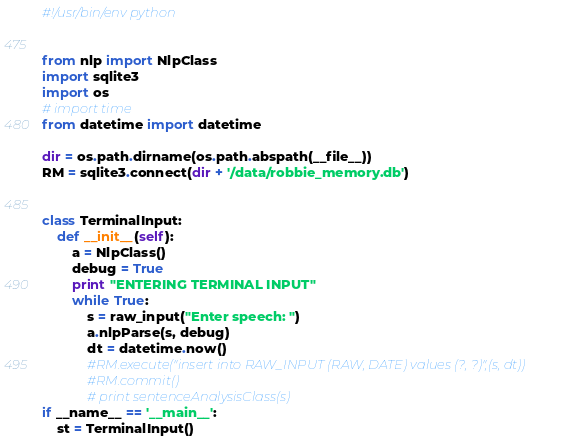Convert code to text. <code><loc_0><loc_0><loc_500><loc_500><_Python_>#!/usr/bin/env python


from nlp import NlpClass
import sqlite3
import os
# import time
from datetime import datetime

dir = os.path.dirname(os.path.abspath(__file__))
RM = sqlite3.connect(dir + '/data/robbie_memory.db')


class TerminalInput:
    def __init__(self):
        a = NlpClass()
        debug = True
        print "ENTERING TERMINAL INPUT"
        while True:
            s = raw_input("Enter speech: ")
            a.nlpParse(s, debug)
            dt = datetime.now()
            #RM.execute("insert into RAW_INPUT (RAW, DATE) values (?, ?)",(s, dt))
            #RM.commit()
            # print sentenceAnalysisClass(s)
if __name__ == '__main__':
    st = TerminalInput()
</code> 